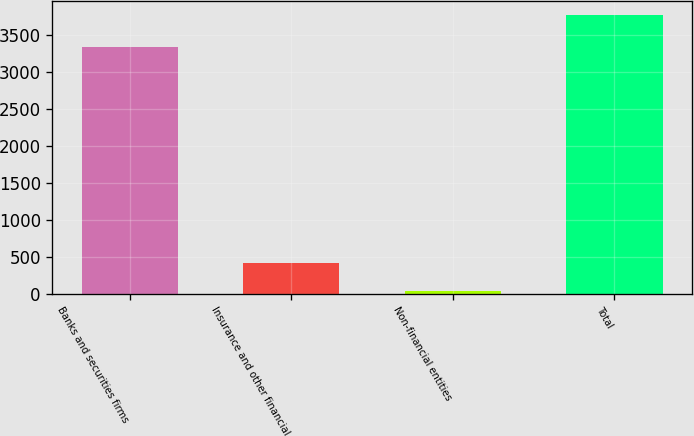Convert chart. <chart><loc_0><loc_0><loc_500><loc_500><bar_chart><fcel>Banks and securities firms<fcel>Insurance and other financial<fcel>Non-financial entities<fcel>Total<nl><fcel>3329<fcel>412.4<fcel>39<fcel>3773<nl></chart> 